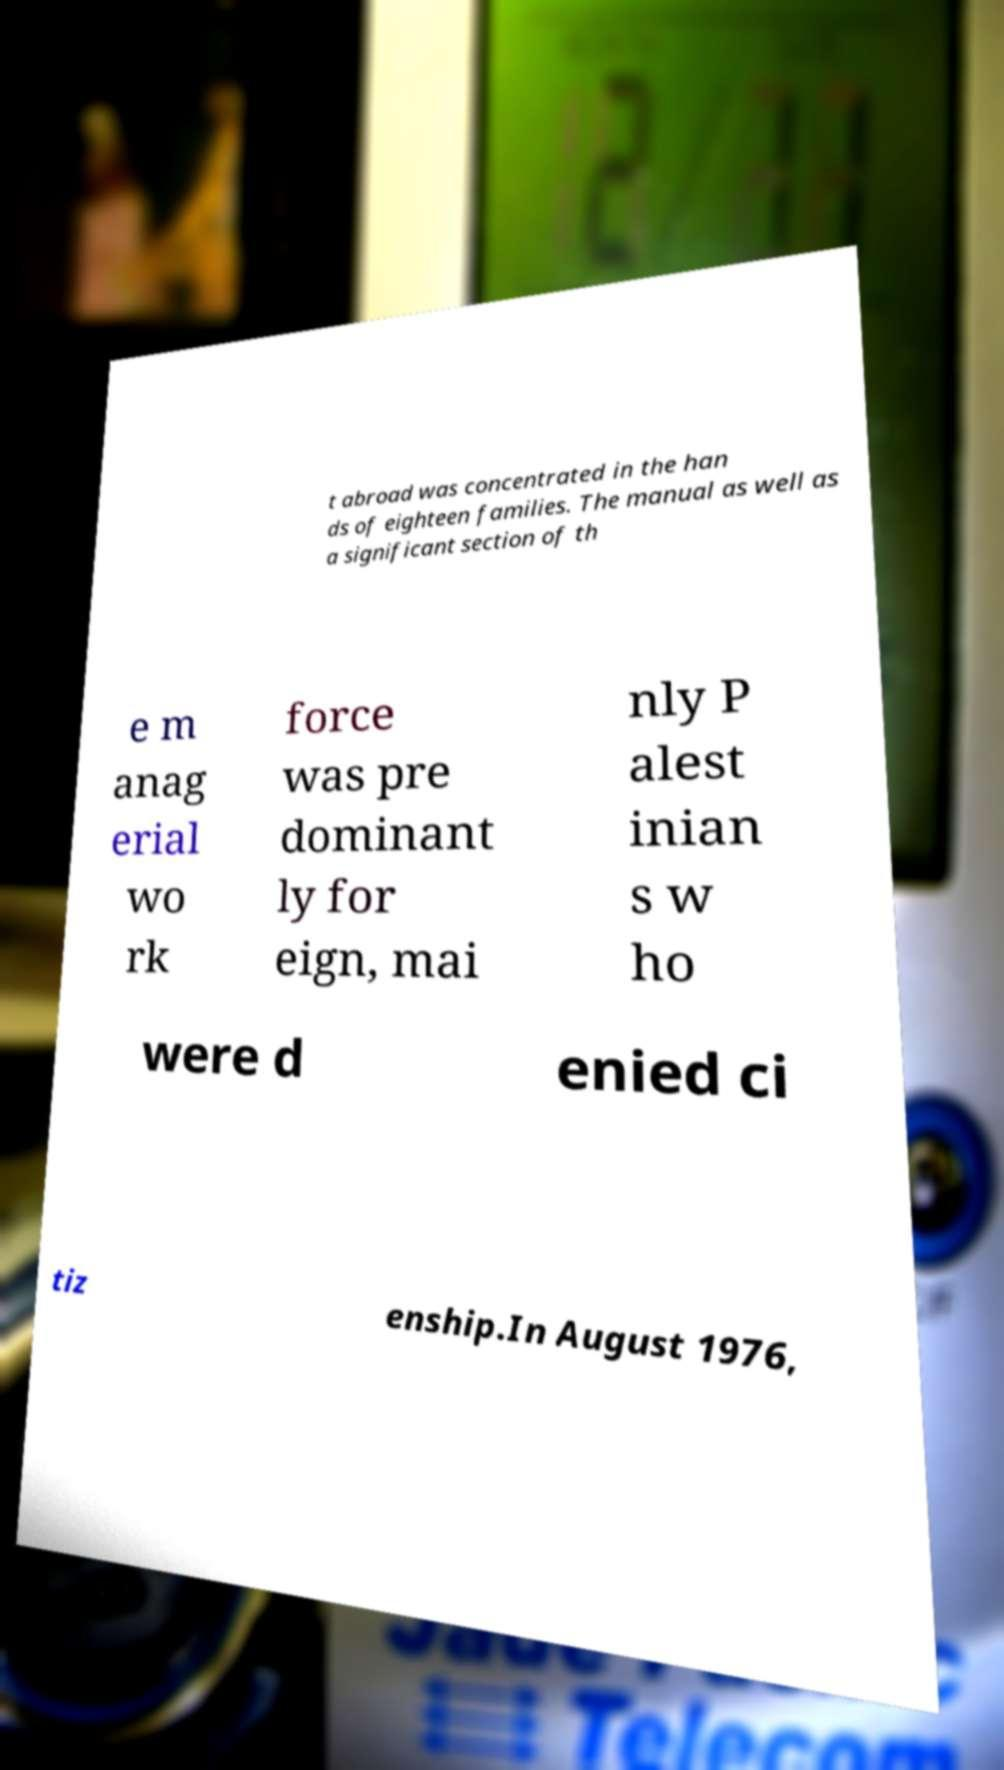Could you assist in decoding the text presented in this image and type it out clearly? t abroad was concentrated in the han ds of eighteen families. The manual as well as a significant section of th e m anag erial wo rk force was pre dominant ly for eign, mai nly P alest inian s w ho were d enied ci tiz enship.In August 1976, 